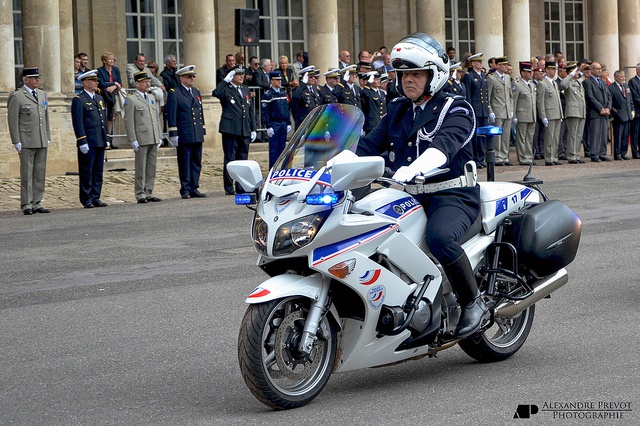Describe the objects in this image and their specific colors. I can see motorcycle in darkgray, black, gray, and lightgray tones, people in darkgray, black, and gray tones, people in darkgray, black, navy, white, and gray tones, people in darkgray, gray, and black tones, and people in darkgray, black, navy, and gray tones in this image. 